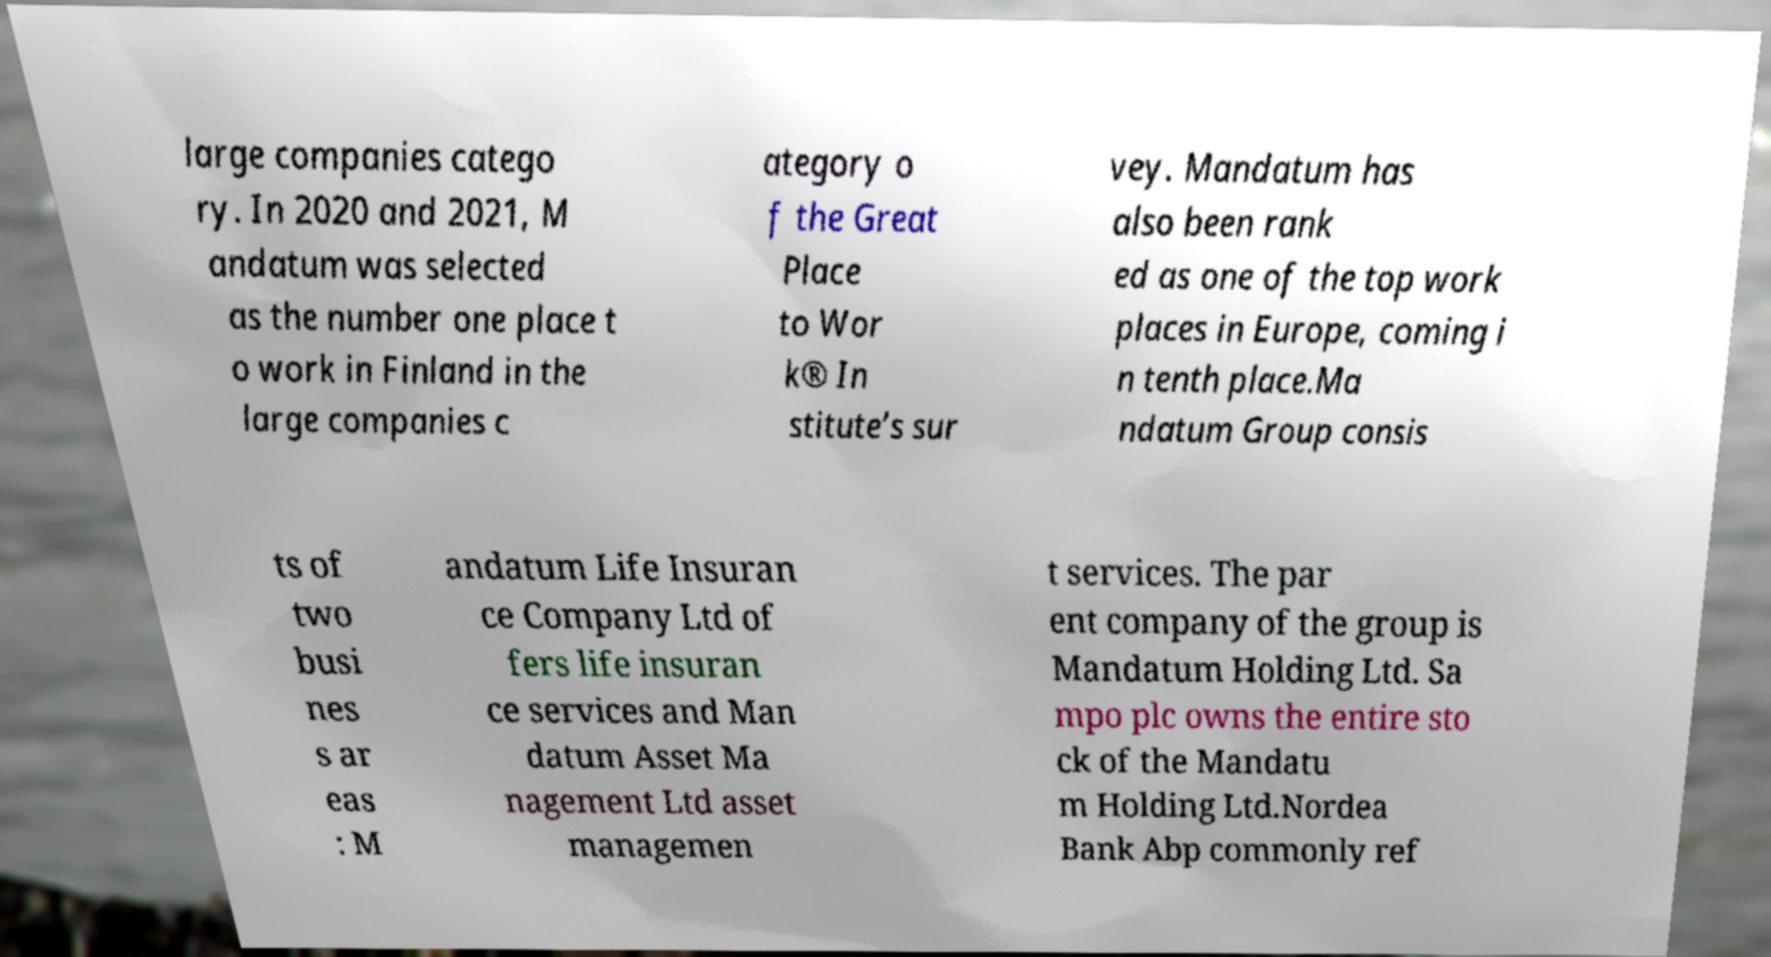There's text embedded in this image that I need extracted. Can you transcribe it verbatim? large companies catego ry. In 2020 and 2021, M andatum was selected as the number one place t o work in Finland in the large companies c ategory o f the Great Place to Wor k® In stitute’s sur vey. Mandatum has also been rank ed as one of the top work places in Europe, coming i n tenth place.Ma ndatum Group consis ts of two busi nes s ar eas : M andatum Life Insuran ce Company Ltd of fers life insuran ce services and Man datum Asset Ma nagement Ltd asset managemen t services. The par ent company of the group is Mandatum Holding Ltd. Sa mpo plc owns the entire sto ck of the Mandatu m Holding Ltd.Nordea Bank Abp commonly ref 